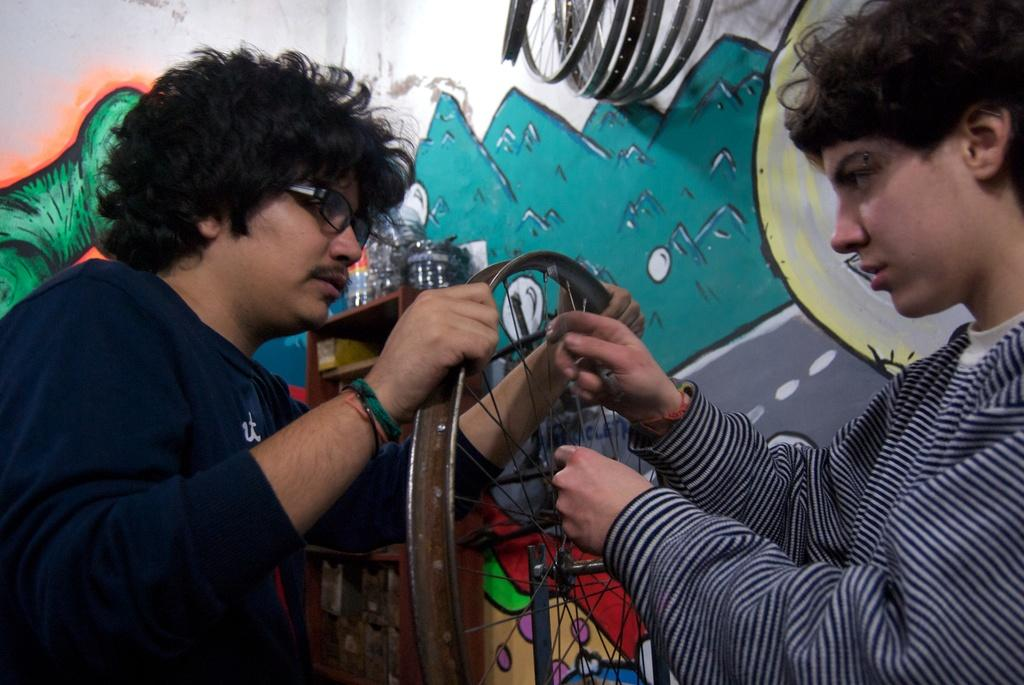How many people are in the image? There are two people in the image. What are the people wearing? Both people are wearing clothes. Can you describe one of the people's appearance? One of the people is wearing spectacles. What can be seen in the image besides the people? There is a wheel, a wall, and a painting on the wall in the image. What type of lunch is being served in the basket in the image? There is no lunch or basket present in the image. Can you tell me what request the people are making in the image? There is no indication of a request being made in the image. 